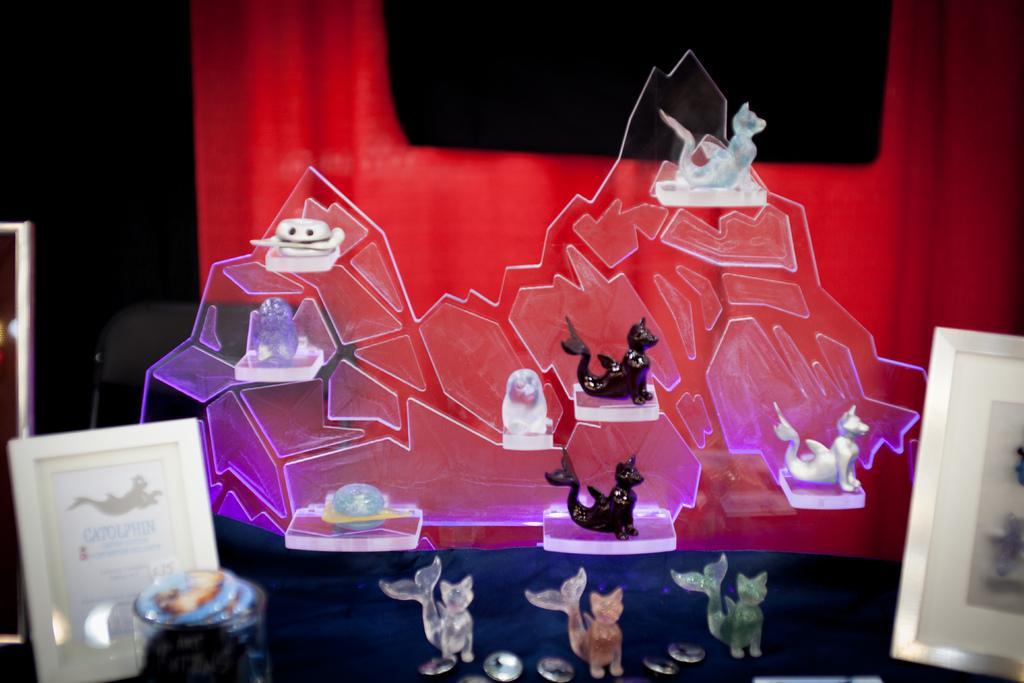Could you give a brief overview of what you see in this image? In the center of this picture we can see there are some objects seems to be the showpiece of animals and showpiece of some objects and we can see the frames and some objects. In the background we can see the chair, red color curtain and many other objects and we can see the text and some pictures. 